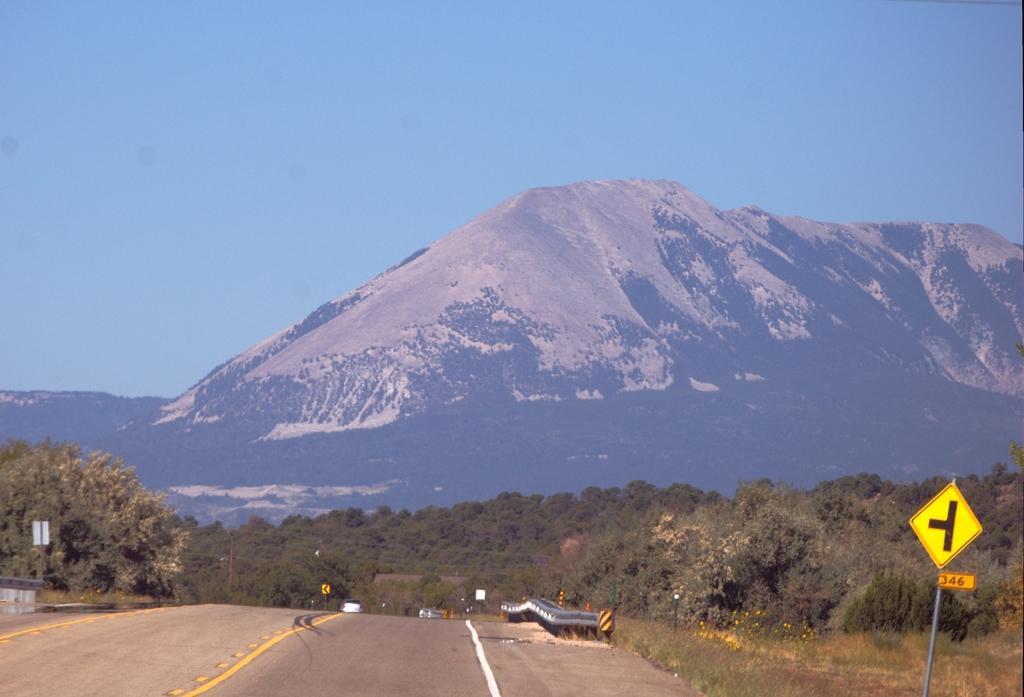How would you summarize this image in a sentence or two? This image is clicked on the road. There are vehicles moving on the road. Beside the road there are sign board poles. In the background there are trees, grass and mountains. At the top there is the sky. 